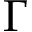Convert formula to latex. <formula><loc_0><loc_0><loc_500><loc_500>\Gamma</formula> 